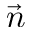<formula> <loc_0><loc_0><loc_500><loc_500>\vec { n }</formula> 